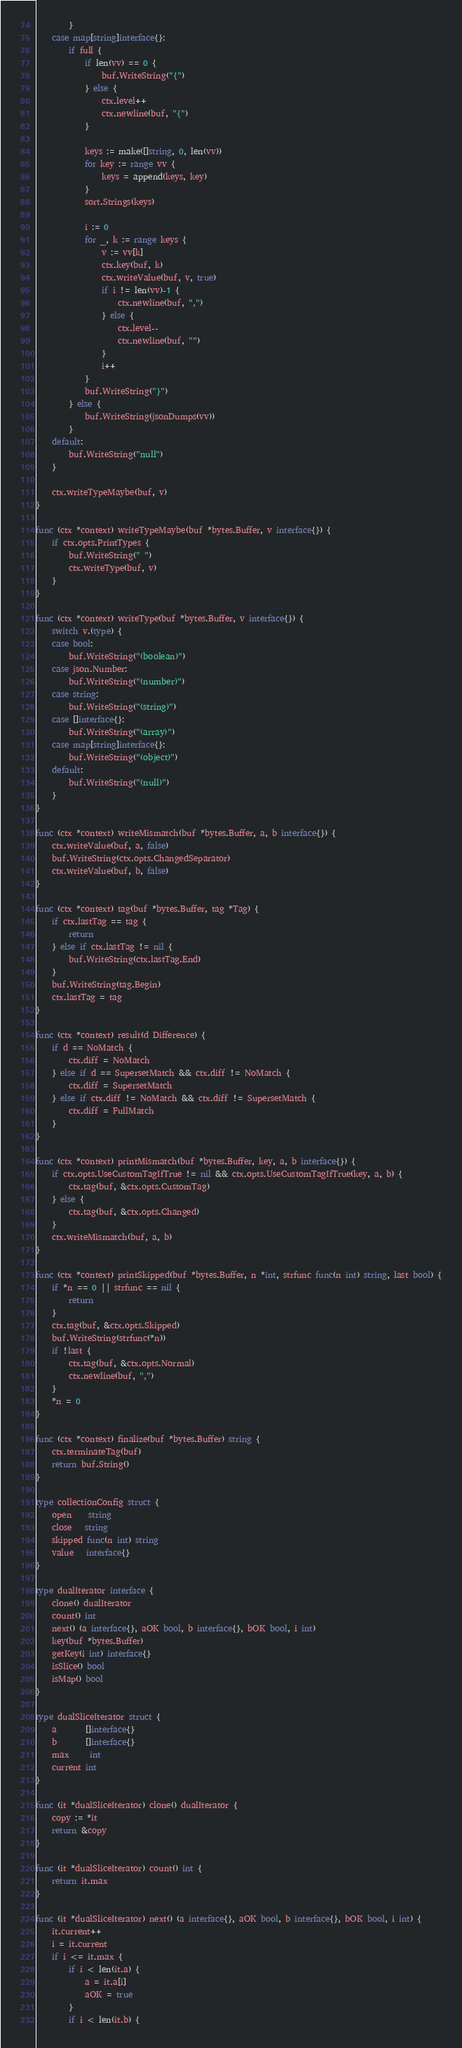<code> <loc_0><loc_0><loc_500><loc_500><_Go_>		}
	case map[string]interface{}:
		if full {
			if len(vv) == 0 {
				buf.WriteString("{")
			} else {
				ctx.level++
				ctx.newline(buf, "{")
			}

			keys := make([]string, 0, len(vv))
			for key := range vv {
				keys = append(keys, key)
			}
			sort.Strings(keys)

			i := 0
			for _, k := range keys {
				v := vv[k]
				ctx.key(buf, k)
				ctx.writeValue(buf, v, true)
				if i != len(vv)-1 {
					ctx.newline(buf, ",")
				} else {
					ctx.level--
					ctx.newline(buf, "")
				}
				i++
			}
			buf.WriteString("}")
		} else {
			buf.WriteString(jsonDumps(vv))
		}
	default:
		buf.WriteString("null")
	}

	ctx.writeTypeMaybe(buf, v)
}

func (ctx *context) writeTypeMaybe(buf *bytes.Buffer, v interface{}) {
	if ctx.opts.PrintTypes {
		buf.WriteString(" ")
		ctx.writeType(buf, v)
	}
}

func (ctx *context) writeType(buf *bytes.Buffer, v interface{}) {
	switch v.(type) {
	case bool:
		buf.WriteString("(boolean)")
	case json.Number:
		buf.WriteString("(number)")
	case string:
		buf.WriteString("(string)")
	case []interface{}:
		buf.WriteString("(array)")
	case map[string]interface{}:
		buf.WriteString("(object)")
	default:
		buf.WriteString("(null)")
	}
}

func (ctx *context) writeMismatch(buf *bytes.Buffer, a, b interface{}) {
	ctx.writeValue(buf, a, false)
	buf.WriteString(ctx.opts.ChangedSeparator)
	ctx.writeValue(buf, b, false)
}

func (ctx *context) tag(buf *bytes.Buffer, tag *Tag) {
	if ctx.lastTag == tag {
		return
	} else if ctx.lastTag != nil {
		buf.WriteString(ctx.lastTag.End)
	}
	buf.WriteString(tag.Begin)
	ctx.lastTag = tag
}

func (ctx *context) result(d Difference) {
	if d == NoMatch {
		ctx.diff = NoMatch
	} else if d == SupersetMatch && ctx.diff != NoMatch {
		ctx.diff = SupersetMatch
	} else if ctx.diff != NoMatch && ctx.diff != SupersetMatch {
		ctx.diff = FullMatch
	}
}

func (ctx *context) printMismatch(buf *bytes.Buffer, key, a, b interface{}) {
	if ctx.opts.UseCustomTagIfTrue != nil && ctx.opts.UseCustomTagIfTrue(key, a, b) {
		ctx.tag(buf, &ctx.opts.CustomTag)
	} else {
		ctx.tag(buf, &ctx.opts.Changed)
	}
	ctx.writeMismatch(buf, a, b)
}

func (ctx *context) printSkipped(buf *bytes.Buffer, n *int, strfunc func(n int) string, last bool) {
	if *n == 0 || strfunc == nil {
		return
	}
	ctx.tag(buf, &ctx.opts.Skipped)
	buf.WriteString(strfunc(*n))
	if !last {
		ctx.tag(buf, &ctx.opts.Normal)
		ctx.newline(buf, ",")
	}
	*n = 0
}

func (ctx *context) finalize(buf *bytes.Buffer) string {
	ctx.terminateTag(buf)
	return buf.String()
}

type collectionConfig struct {
	open    string
	close   string
	skipped func(n int) string
	value   interface{}
}

type dualIterator interface {
	clone() dualIterator
	count() int
	next() (a interface{}, aOK bool, b interface{}, bOK bool, i int)
	key(buf *bytes.Buffer)
	getKey(i int) interface{}
	isSlice() bool
	isMap() bool
}

type dualSliceIterator struct {
	a       []interface{}
	b       []interface{}
	max     int
	current int
}

func (it *dualSliceIterator) clone() dualIterator {
	copy := *it
	return &copy
}

func (it *dualSliceIterator) count() int {
	return it.max
}

func (it *dualSliceIterator) next() (a interface{}, aOK bool, b interface{}, bOK bool, i int) {
	it.current++
	i = it.current
	if i <= it.max {
		if i < len(it.a) {
			a = it.a[i]
			aOK = true
		}
		if i < len(it.b) {</code> 